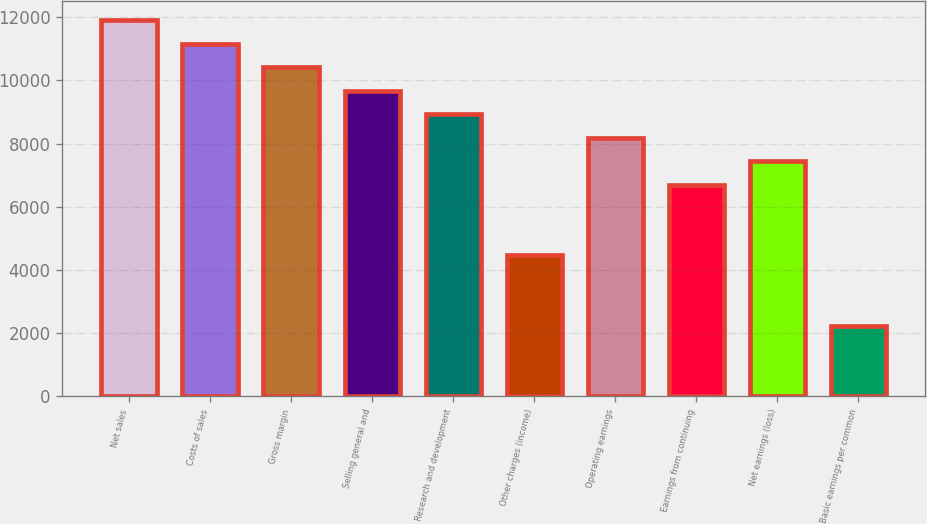<chart> <loc_0><loc_0><loc_500><loc_500><bar_chart><fcel>Net sales<fcel>Costs of sales<fcel>Gross margin<fcel>Selling general and<fcel>Research and development<fcel>Other charges (income)<fcel>Operating earnings<fcel>Earnings from continuing<fcel>Net earnings (loss)<fcel>Basic earnings per common<nl><fcel>11905.6<fcel>11161.5<fcel>10417.4<fcel>9673.34<fcel>8929.24<fcel>4464.64<fcel>8185.14<fcel>6696.94<fcel>7441.04<fcel>2232.34<nl></chart> 